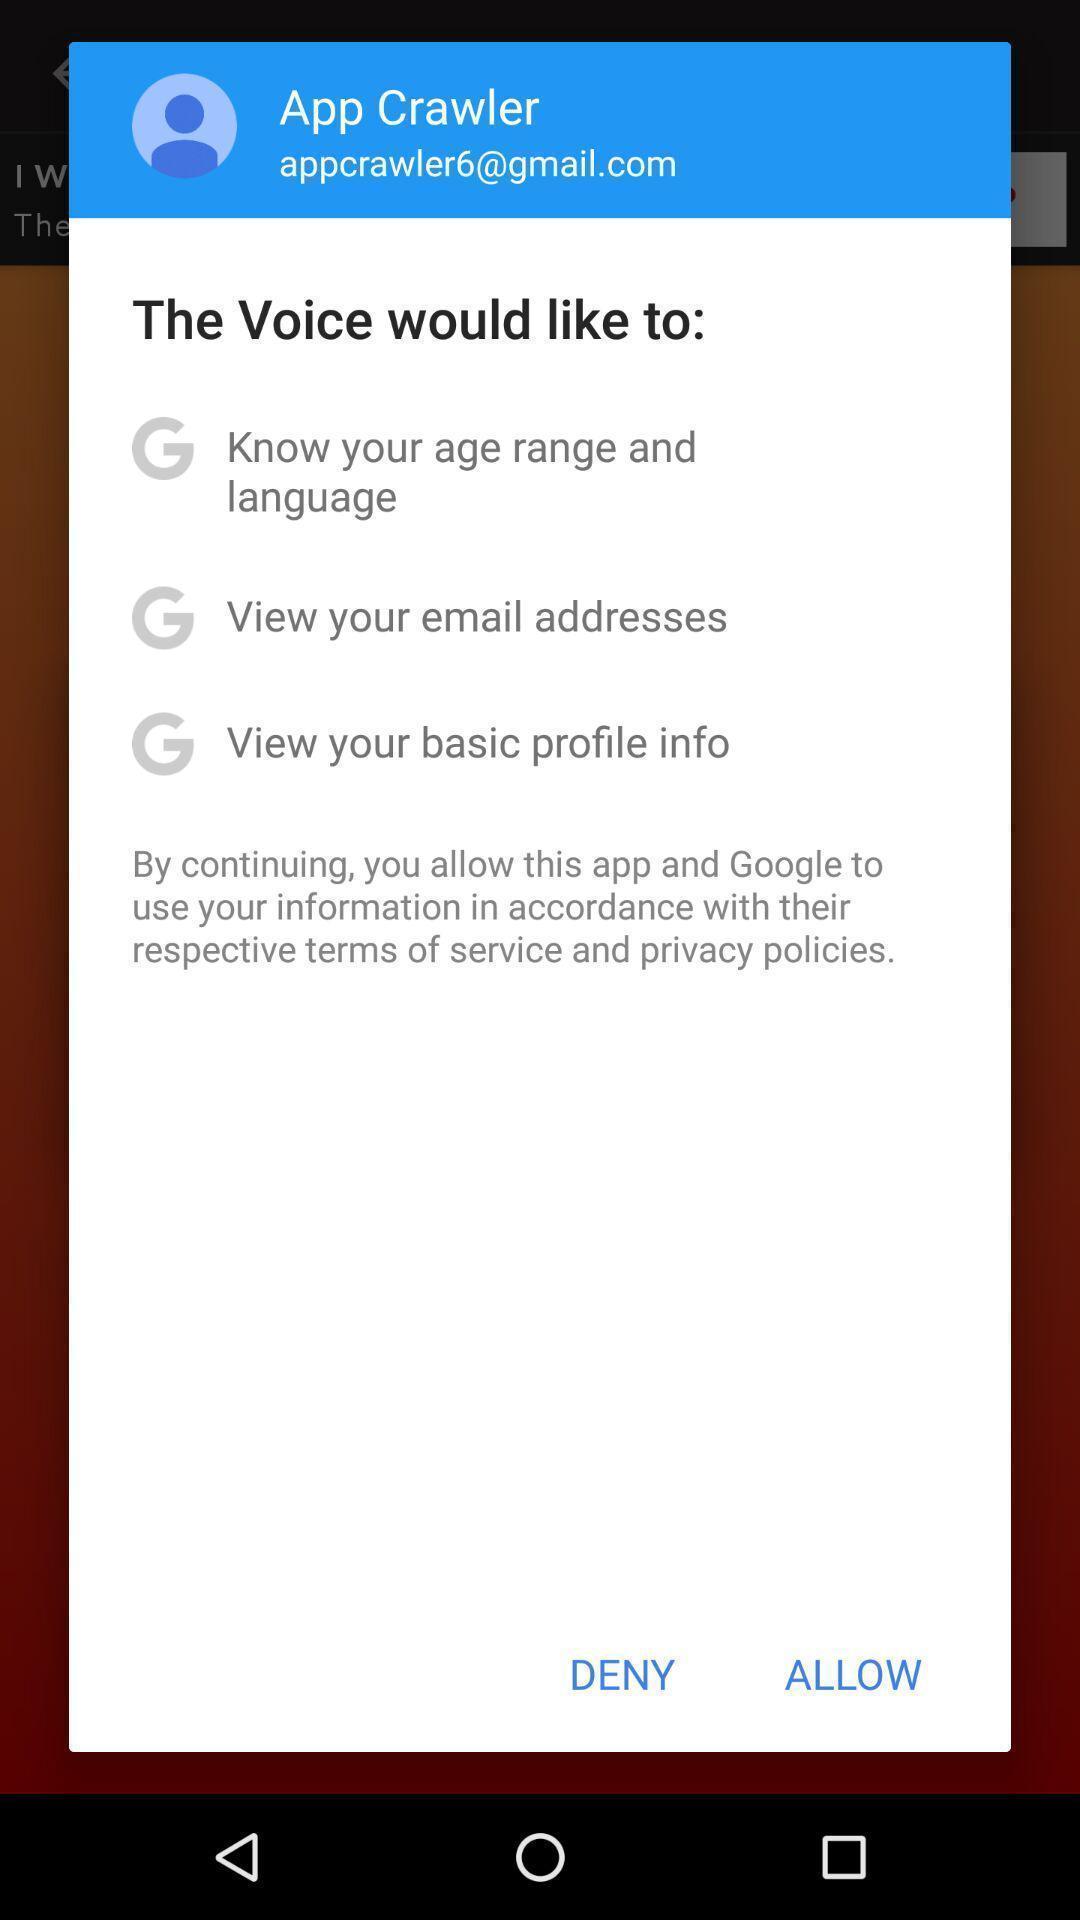Explain what's happening in this screen capture. Pop-up for allow or deny to know age and language. 